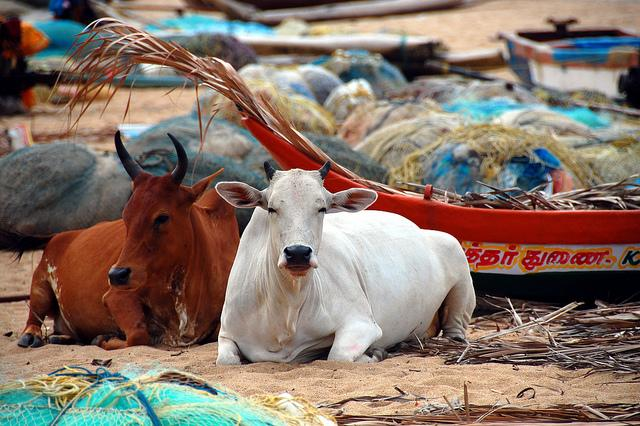What animal has similar things on their head to these animals? bulls 